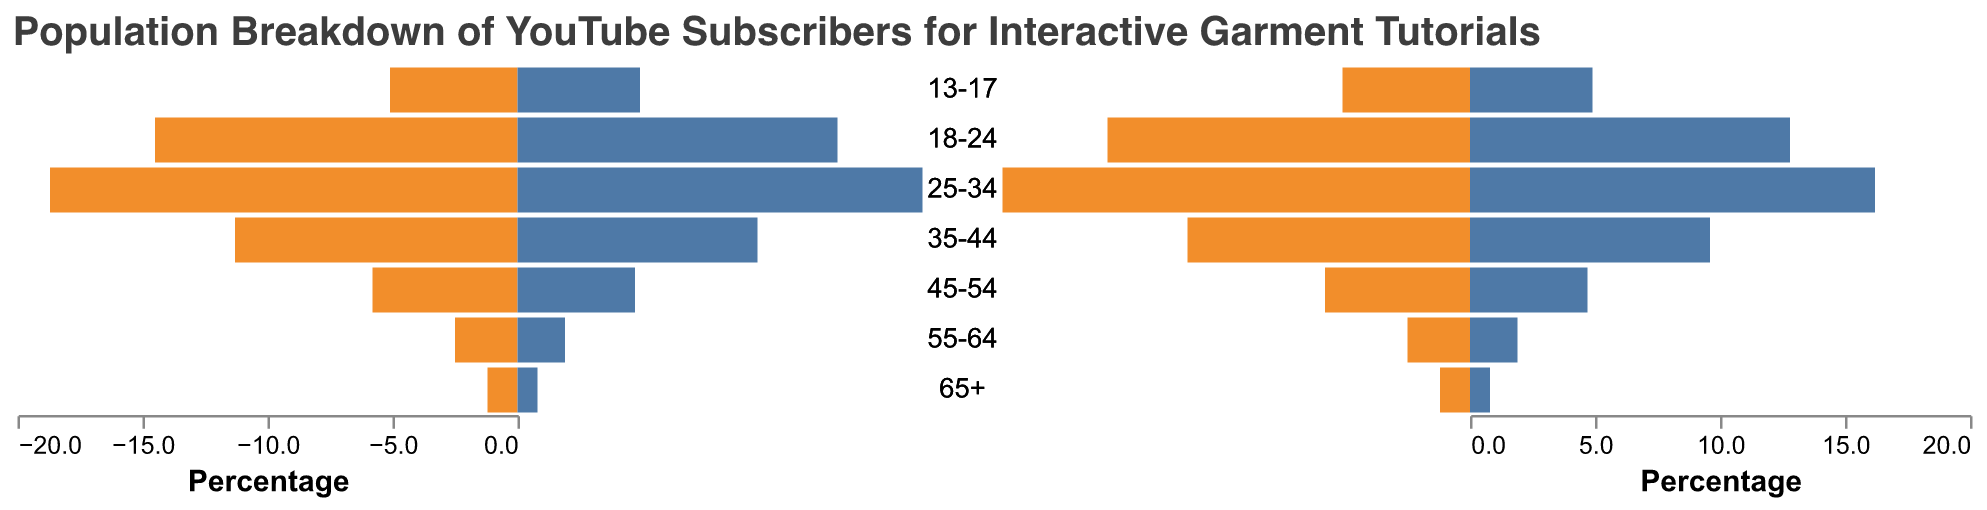What's the title of the chart? The title is written at the top of the chart and provides a summary description of the chart contents.
Answer: Population Breakdown of YouTube Subscribers for Interactive Garment Tutorials Which gender has a higher percentage in the 25-34 age group? By comparing the lengths of the bars for the 25-34 age group, the orange bar (Female) looks slightly smaller than the blue bar (Male).
Answer: Male What is the percentage of females in the 45-54 age group? The orange bar for the 45-54 age group extends to the 4.7% mark on the positive x-axis.
Answer: 4.7% Which age group shows the smallest difference in subscriber percentage between males and females? By visually comparing the bars across all age groups, the 13-17 age group seems to have the closest bar lengths for both genders.
Answer: 13-17 What is the total percentage of subscribers in the 18-24 age group? Sum the percentage of males and females for the 18-24 age group: 14.5% (Male) + 12.8% (Female) = 27.3%.
Answer: 27.3% Compare the male percentage in the 35-44 age group to the female percentage in the same group. Which one is larger and by how much? The blue bar (Male) extends to 11.3%, while the orange bar (Female) extends to 9.6%. The difference is 11.3% - 9.6% = 1.7%.
Answer: Male by 1.7% Which age group has the highest percentage of female subscribers? The orange bar (Female) is longest in the 25-34 age group extending to 16.2%.
Answer: 25-34 Which gender has the least representation in the 65+ age group? The shorter orange bar (Female) extends to 0.8%, while the blue bar (Male) extends to 1.2%.
Answer: Female Calculate the average percentage of male subscribers across all age groups. Add all male percentages and divide by the number of age groups: (1.2 + 2.5 + 5.8 + 11.3 + 18.7 + 14.5 + 5.1) / 7 = 59.1 / 7 ≈ 8.44%.
Answer: 8.44% What is the combined percentage of male subscribers in the 45-54, 55-64, and 65+ age groups? Sum the male percentages in these age groups: 5.8% + 2.5% + 1.2% = 9.5%.
Answer: 9.5% 